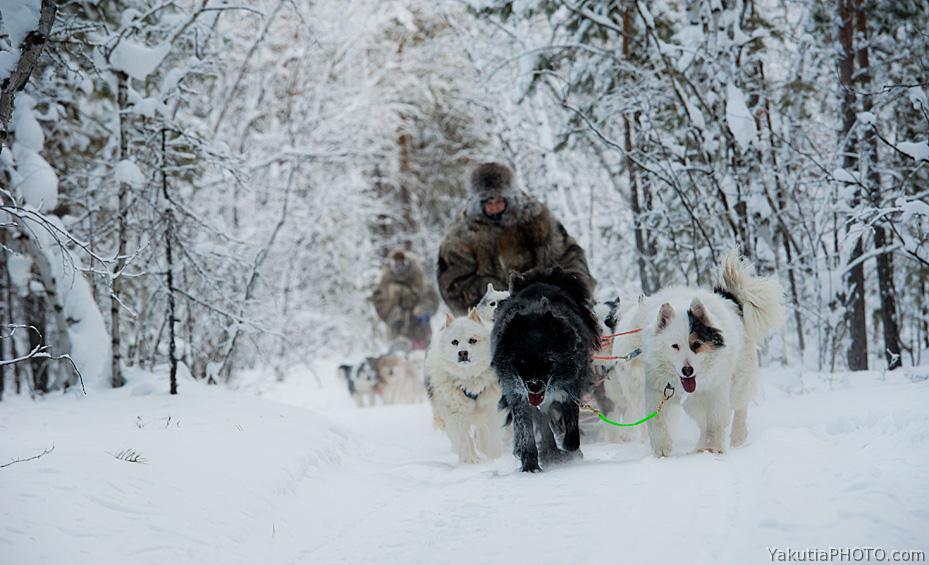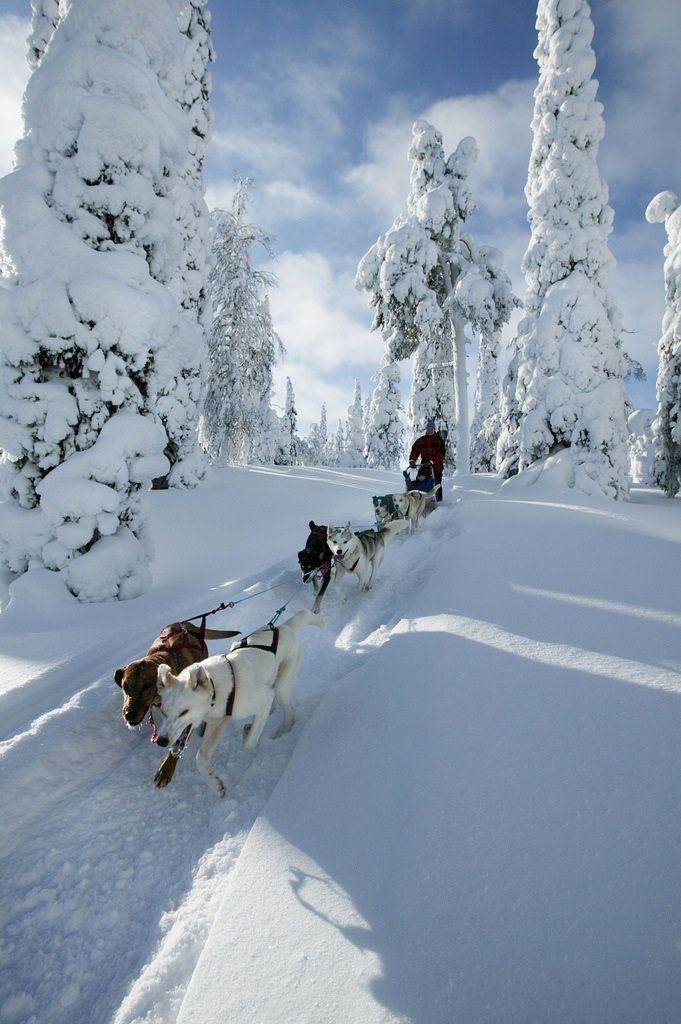The first image is the image on the left, the second image is the image on the right. Examine the images to the left and right. Is the description "One image shows at least one sled dog team moving horizontally rightward, and the other image shows at least one dog team moving forward at some angle." accurate? Answer yes or no. No. The first image is the image on the left, the second image is the image on the right. Analyze the images presented: Is the assertion "There are trees visible in both images." valid? Answer yes or no. Yes. 